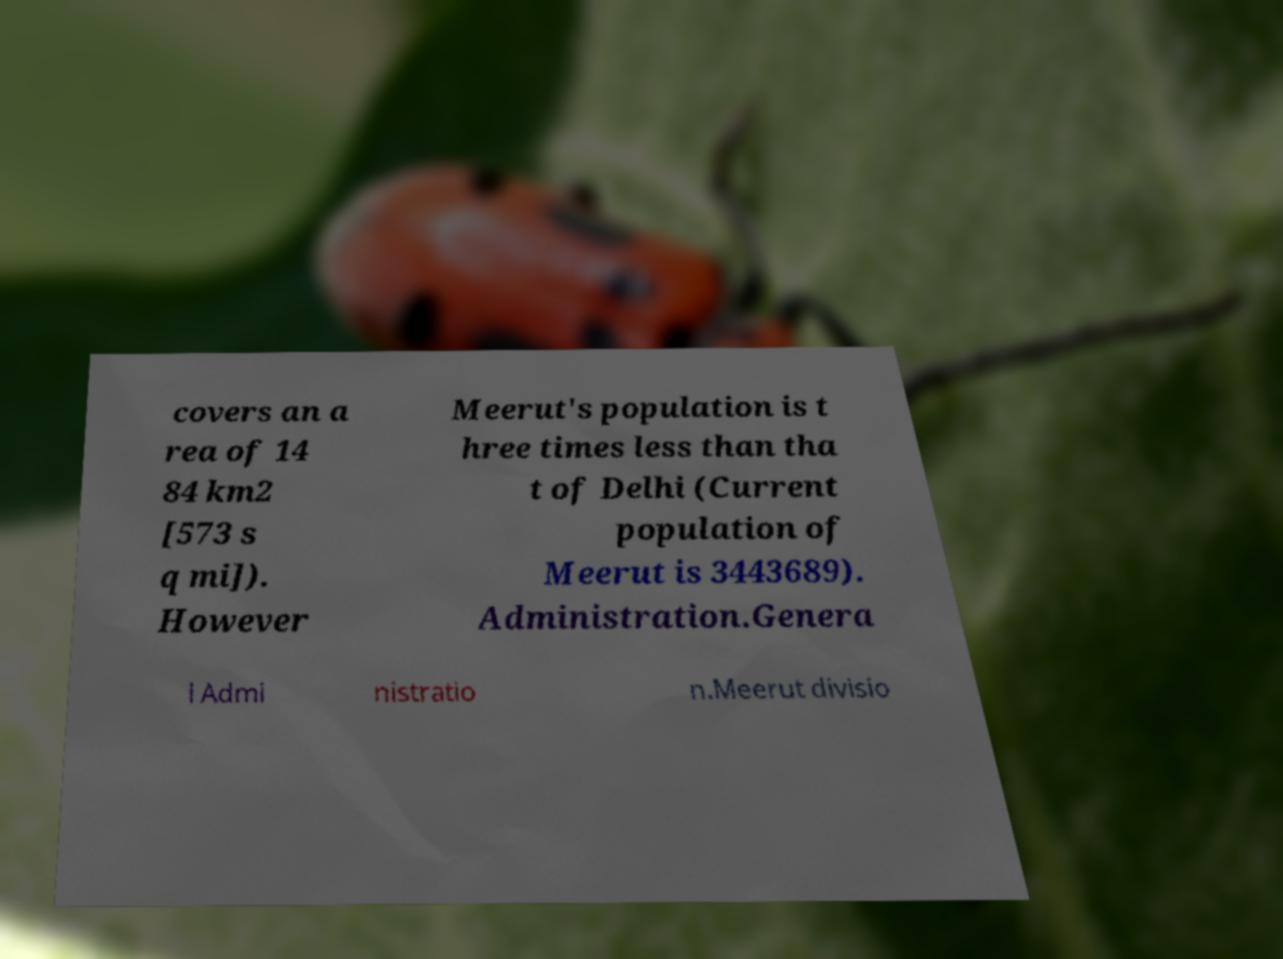I need the written content from this picture converted into text. Can you do that? covers an a rea of 14 84 km2 [573 s q mi]). However Meerut's population is t hree times less than tha t of Delhi (Current population of Meerut is 3443689). Administration.Genera l Admi nistratio n.Meerut divisio 